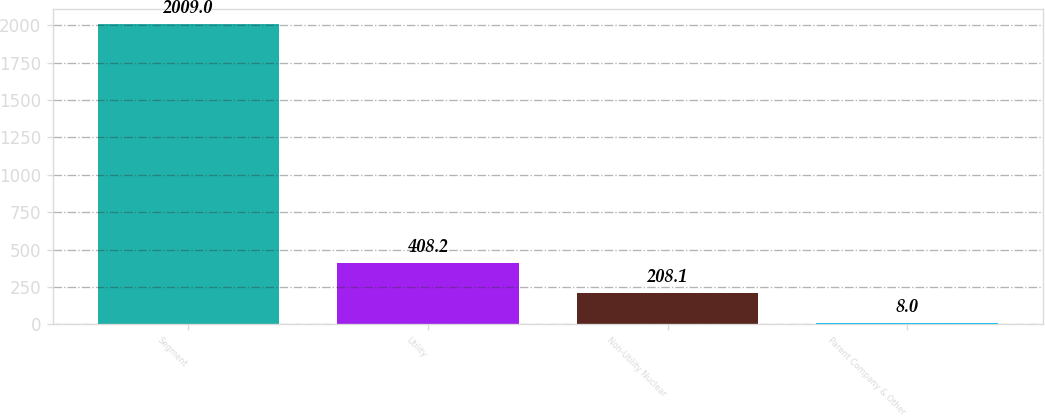Convert chart. <chart><loc_0><loc_0><loc_500><loc_500><bar_chart><fcel>Segment<fcel>Utility<fcel>Non-Utility Nuclear<fcel>Parent Company & Other<nl><fcel>2009<fcel>408.2<fcel>208.1<fcel>8<nl></chart> 